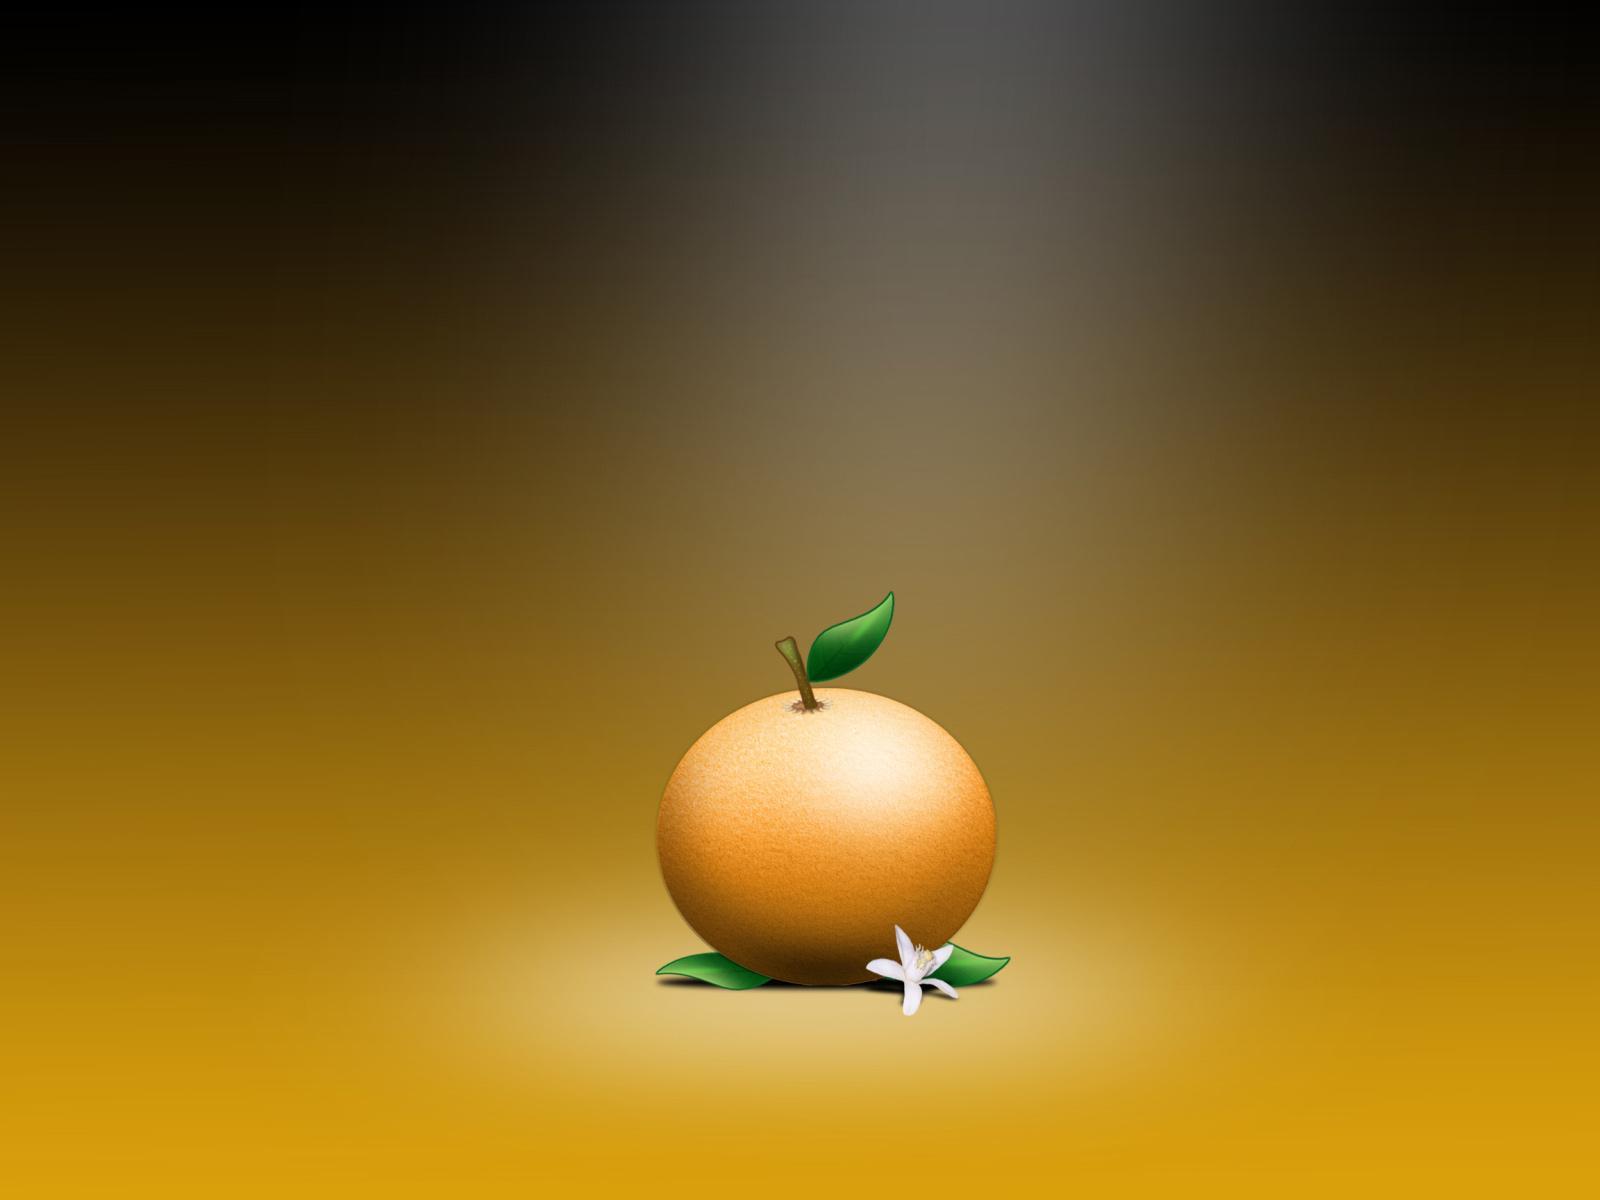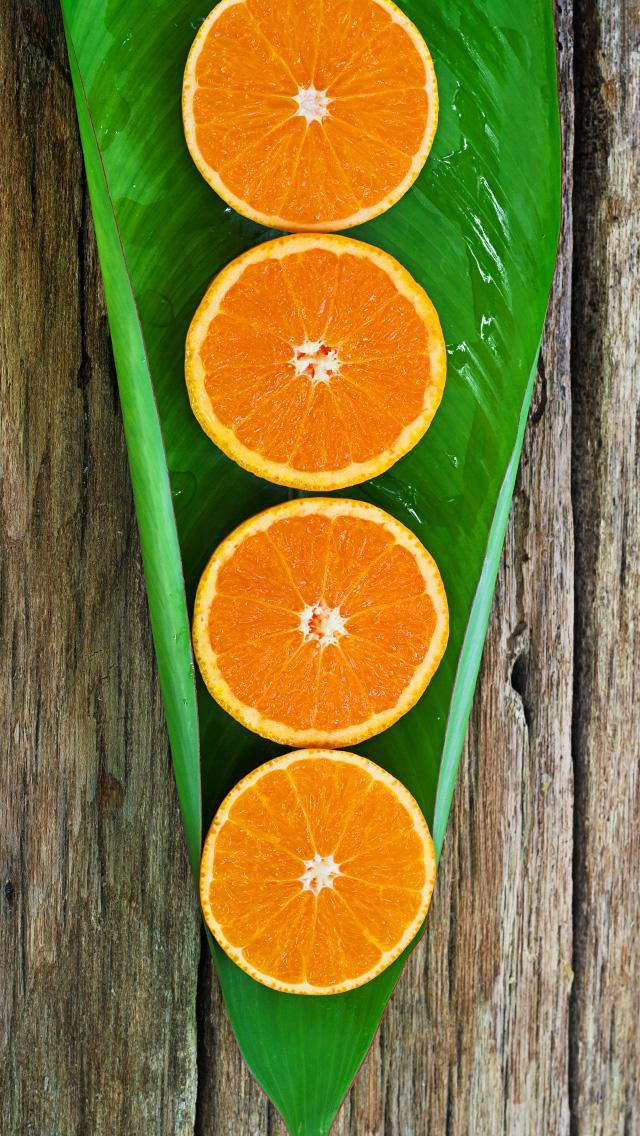The first image is the image on the left, the second image is the image on the right. Given the left and right images, does the statement "The right image features orange fruits growing in a green-leafed tree, and the left image includes a whole orange with green leaves attached." hold true? Answer yes or no. No. The first image is the image on the left, the second image is the image on the right. Examine the images to the left and right. Is the description "The image on the left shows both cut fruit and uncut fruit." accurate? Answer yes or no. No. 